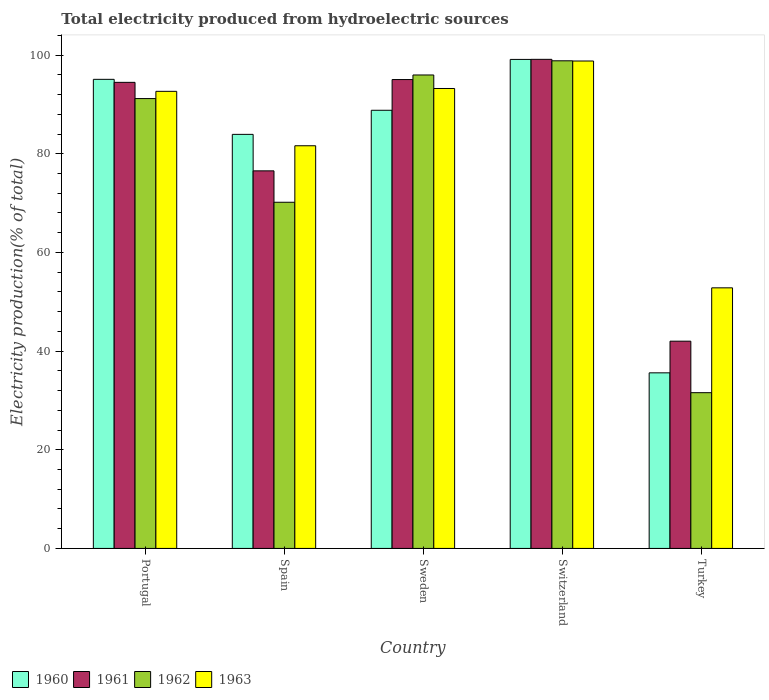How many different coloured bars are there?
Provide a short and direct response. 4. How many groups of bars are there?
Your answer should be very brief. 5. How many bars are there on the 4th tick from the left?
Offer a terse response. 4. How many bars are there on the 3rd tick from the right?
Offer a very short reply. 4. What is the total electricity produced in 1960 in Switzerland?
Keep it short and to the point. 99.13. Across all countries, what is the maximum total electricity produced in 1960?
Your answer should be compact. 99.13. Across all countries, what is the minimum total electricity produced in 1963?
Offer a terse response. 52.82. In which country was the total electricity produced in 1961 maximum?
Provide a short and direct response. Switzerland. In which country was the total electricity produced in 1963 minimum?
Offer a very short reply. Turkey. What is the total total electricity produced in 1963 in the graph?
Offer a terse response. 419.15. What is the difference between the total electricity produced in 1960 in Portugal and that in Switzerland?
Your answer should be compact. -4.04. What is the difference between the total electricity produced in 1961 in Sweden and the total electricity produced in 1963 in Switzerland?
Offer a terse response. -3.76. What is the average total electricity produced in 1963 per country?
Provide a succinct answer. 83.83. What is the difference between the total electricity produced of/in 1963 and total electricity produced of/in 1961 in Spain?
Give a very brief answer. 5.09. What is the ratio of the total electricity produced in 1963 in Spain to that in Turkey?
Make the answer very short. 1.55. Is the total electricity produced in 1963 in Portugal less than that in Switzerland?
Offer a very short reply. Yes. What is the difference between the highest and the second highest total electricity produced in 1962?
Your response must be concise. 7.65. What is the difference between the highest and the lowest total electricity produced in 1960?
Ensure brevity in your answer.  63.54. Is the sum of the total electricity produced in 1960 in Switzerland and Turkey greater than the maximum total electricity produced in 1962 across all countries?
Your response must be concise. Yes. Is it the case that in every country, the sum of the total electricity produced in 1962 and total electricity produced in 1960 is greater than the sum of total electricity produced in 1961 and total electricity produced in 1963?
Make the answer very short. No. What does the 3rd bar from the left in Portugal represents?
Offer a terse response. 1962. Is it the case that in every country, the sum of the total electricity produced in 1961 and total electricity produced in 1963 is greater than the total electricity produced in 1960?
Keep it short and to the point. Yes. How many countries are there in the graph?
Make the answer very short. 5. What is the difference between two consecutive major ticks on the Y-axis?
Ensure brevity in your answer.  20. Where does the legend appear in the graph?
Your response must be concise. Bottom left. How many legend labels are there?
Your answer should be very brief. 4. How are the legend labels stacked?
Offer a terse response. Horizontal. What is the title of the graph?
Keep it short and to the point. Total electricity produced from hydroelectric sources. What is the label or title of the X-axis?
Your answer should be compact. Country. What is the label or title of the Y-axis?
Give a very brief answer. Electricity production(% of total). What is the Electricity production(% of total) of 1960 in Portugal?
Your answer should be very brief. 95.09. What is the Electricity production(% of total) of 1961 in Portugal?
Your response must be concise. 94.48. What is the Electricity production(% of total) in 1962 in Portugal?
Offer a terse response. 91.19. What is the Electricity production(% of total) of 1963 in Portugal?
Keep it short and to the point. 92.66. What is the Electricity production(% of total) in 1960 in Spain?
Make the answer very short. 83.94. What is the Electricity production(% of total) in 1961 in Spain?
Make the answer very short. 76.54. What is the Electricity production(% of total) in 1962 in Spain?
Ensure brevity in your answer.  70.17. What is the Electricity production(% of total) in 1963 in Spain?
Provide a succinct answer. 81.63. What is the Electricity production(% of total) in 1960 in Sweden?
Provide a short and direct response. 88.82. What is the Electricity production(% of total) in 1961 in Sweden?
Your response must be concise. 95.05. What is the Electricity production(% of total) of 1962 in Sweden?
Your response must be concise. 95.98. What is the Electricity production(% of total) in 1963 in Sweden?
Give a very brief answer. 93.24. What is the Electricity production(% of total) in 1960 in Switzerland?
Your answer should be very brief. 99.13. What is the Electricity production(% of total) of 1961 in Switzerland?
Your answer should be compact. 99.15. What is the Electricity production(% of total) in 1962 in Switzerland?
Your answer should be very brief. 98.85. What is the Electricity production(% of total) of 1963 in Switzerland?
Provide a succinct answer. 98.81. What is the Electricity production(% of total) of 1960 in Turkey?
Make the answer very short. 35.6. What is the Electricity production(% of total) in 1961 in Turkey?
Offer a terse response. 42.01. What is the Electricity production(% of total) in 1962 in Turkey?
Your answer should be compact. 31.57. What is the Electricity production(% of total) of 1963 in Turkey?
Keep it short and to the point. 52.82. Across all countries, what is the maximum Electricity production(% of total) of 1960?
Provide a short and direct response. 99.13. Across all countries, what is the maximum Electricity production(% of total) of 1961?
Your answer should be compact. 99.15. Across all countries, what is the maximum Electricity production(% of total) of 1962?
Your response must be concise. 98.85. Across all countries, what is the maximum Electricity production(% of total) of 1963?
Offer a very short reply. 98.81. Across all countries, what is the minimum Electricity production(% of total) of 1960?
Provide a short and direct response. 35.6. Across all countries, what is the minimum Electricity production(% of total) in 1961?
Your response must be concise. 42.01. Across all countries, what is the minimum Electricity production(% of total) of 1962?
Your answer should be very brief. 31.57. Across all countries, what is the minimum Electricity production(% of total) in 1963?
Keep it short and to the point. 52.82. What is the total Electricity production(% of total) in 1960 in the graph?
Ensure brevity in your answer.  402.57. What is the total Electricity production(% of total) of 1961 in the graph?
Make the answer very short. 407.23. What is the total Electricity production(% of total) in 1962 in the graph?
Ensure brevity in your answer.  387.76. What is the total Electricity production(% of total) in 1963 in the graph?
Ensure brevity in your answer.  419.15. What is the difference between the Electricity production(% of total) of 1960 in Portugal and that in Spain?
Offer a very short reply. 11.15. What is the difference between the Electricity production(% of total) in 1961 in Portugal and that in Spain?
Give a very brief answer. 17.94. What is the difference between the Electricity production(% of total) of 1962 in Portugal and that in Spain?
Make the answer very short. 21.02. What is the difference between the Electricity production(% of total) of 1963 in Portugal and that in Spain?
Offer a terse response. 11.03. What is the difference between the Electricity production(% of total) in 1960 in Portugal and that in Sweden?
Provide a succinct answer. 6.27. What is the difference between the Electricity production(% of total) of 1961 in Portugal and that in Sweden?
Provide a short and direct response. -0.57. What is the difference between the Electricity production(% of total) in 1962 in Portugal and that in Sweden?
Keep it short and to the point. -4.78. What is the difference between the Electricity production(% of total) of 1963 in Portugal and that in Sweden?
Provide a succinct answer. -0.58. What is the difference between the Electricity production(% of total) in 1960 in Portugal and that in Switzerland?
Give a very brief answer. -4.04. What is the difference between the Electricity production(% of total) of 1961 in Portugal and that in Switzerland?
Your response must be concise. -4.67. What is the difference between the Electricity production(% of total) of 1962 in Portugal and that in Switzerland?
Offer a very short reply. -7.65. What is the difference between the Electricity production(% of total) of 1963 in Portugal and that in Switzerland?
Ensure brevity in your answer.  -6.15. What is the difference between the Electricity production(% of total) in 1960 in Portugal and that in Turkey?
Offer a very short reply. 59.49. What is the difference between the Electricity production(% of total) in 1961 in Portugal and that in Turkey?
Your answer should be compact. 52.47. What is the difference between the Electricity production(% of total) in 1962 in Portugal and that in Turkey?
Your answer should be compact. 59.62. What is the difference between the Electricity production(% of total) in 1963 in Portugal and that in Turkey?
Offer a very short reply. 39.84. What is the difference between the Electricity production(% of total) of 1960 in Spain and that in Sweden?
Your answer should be compact. -4.88. What is the difference between the Electricity production(% of total) in 1961 in Spain and that in Sweden?
Provide a short and direct response. -18.51. What is the difference between the Electricity production(% of total) of 1962 in Spain and that in Sweden?
Your answer should be very brief. -25.8. What is the difference between the Electricity production(% of total) in 1963 in Spain and that in Sweden?
Ensure brevity in your answer.  -11.61. What is the difference between the Electricity production(% of total) of 1960 in Spain and that in Switzerland?
Keep it short and to the point. -15.19. What is the difference between the Electricity production(% of total) in 1961 in Spain and that in Switzerland?
Provide a succinct answer. -22.61. What is the difference between the Electricity production(% of total) in 1962 in Spain and that in Switzerland?
Offer a terse response. -28.67. What is the difference between the Electricity production(% of total) of 1963 in Spain and that in Switzerland?
Offer a very short reply. -17.18. What is the difference between the Electricity production(% of total) in 1960 in Spain and that in Turkey?
Your response must be concise. 48.34. What is the difference between the Electricity production(% of total) in 1961 in Spain and that in Turkey?
Keep it short and to the point. 34.53. What is the difference between the Electricity production(% of total) in 1962 in Spain and that in Turkey?
Your answer should be compact. 38.6. What is the difference between the Electricity production(% of total) in 1963 in Spain and that in Turkey?
Provide a succinct answer. 28.8. What is the difference between the Electricity production(% of total) in 1960 in Sweden and that in Switzerland?
Provide a succinct answer. -10.31. What is the difference between the Electricity production(% of total) of 1961 in Sweden and that in Switzerland?
Keep it short and to the point. -4.1. What is the difference between the Electricity production(% of total) of 1962 in Sweden and that in Switzerland?
Provide a succinct answer. -2.87. What is the difference between the Electricity production(% of total) of 1963 in Sweden and that in Switzerland?
Your answer should be very brief. -5.57. What is the difference between the Electricity production(% of total) in 1960 in Sweden and that in Turkey?
Keep it short and to the point. 53.22. What is the difference between the Electricity production(% of total) of 1961 in Sweden and that in Turkey?
Give a very brief answer. 53.04. What is the difference between the Electricity production(% of total) in 1962 in Sweden and that in Turkey?
Keep it short and to the point. 64.4. What is the difference between the Electricity production(% of total) of 1963 in Sweden and that in Turkey?
Ensure brevity in your answer.  40.41. What is the difference between the Electricity production(% of total) of 1960 in Switzerland and that in Turkey?
Provide a succinct answer. 63.54. What is the difference between the Electricity production(% of total) of 1961 in Switzerland and that in Turkey?
Give a very brief answer. 57.13. What is the difference between the Electricity production(% of total) in 1962 in Switzerland and that in Turkey?
Provide a short and direct response. 67.27. What is the difference between the Electricity production(% of total) in 1963 in Switzerland and that in Turkey?
Your response must be concise. 45.98. What is the difference between the Electricity production(% of total) of 1960 in Portugal and the Electricity production(% of total) of 1961 in Spain?
Your answer should be compact. 18.55. What is the difference between the Electricity production(% of total) of 1960 in Portugal and the Electricity production(% of total) of 1962 in Spain?
Ensure brevity in your answer.  24.92. What is the difference between the Electricity production(% of total) in 1960 in Portugal and the Electricity production(% of total) in 1963 in Spain?
Your answer should be compact. 13.46. What is the difference between the Electricity production(% of total) in 1961 in Portugal and the Electricity production(% of total) in 1962 in Spain?
Make the answer very short. 24.31. What is the difference between the Electricity production(% of total) in 1961 in Portugal and the Electricity production(% of total) in 1963 in Spain?
Provide a short and direct response. 12.85. What is the difference between the Electricity production(% of total) of 1962 in Portugal and the Electricity production(% of total) of 1963 in Spain?
Your answer should be very brief. 9.57. What is the difference between the Electricity production(% of total) in 1960 in Portugal and the Electricity production(% of total) in 1961 in Sweden?
Ensure brevity in your answer.  0.04. What is the difference between the Electricity production(% of total) of 1960 in Portugal and the Electricity production(% of total) of 1962 in Sweden?
Ensure brevity in your answer.  -0.89. What is the difference between the Electricity production(% of total) in 1960 in Portugal and the Electricity production(% of total) in 1963 in Sweden?
Your response must be concise. 1.85. What is the difference between the Electricity production(% of total) of 1961 in Portugal and the Electricity production(% of total) of 1962 in Sweden?
Provide a succinct answer. -1.49. What is the difference between the Electricity production(% of total) of 1961 in Portugal and the Electricity production(% of total) of 1963 in Sweden?
Provide a succinct answer. 1.24. What is the difference between the Electricity production(% of total) in 1962 in Portugal and the Electricity production(% of total) in 1963 in Sweden?
Offer a terse response. -2.04. What is the difference between the Electricity production(% of total) of 1960 in Portugal and the Electricity production(% of total) of 1961 in Switzerland?
Your response must be concise. -4.06. What is the difference between the Electricity production(% of total) in 1960 in Portugal and the Electricity production(% of total) in 1962 in Switzerland?
Provide a short and direct response. -3.76. What is the difference between the Electricity production(% of total) in 1960 in Portugal and the Electricity production(% of total) in 1963 in Switzerland?
Keep it short and to the point. -3.72. What is the difference between the Electricity production(% of total) in 1961 in Portugal and the Electricity production(% of total) in 1962 in Switzerland?
Give a very brief answer. -4.37. What is the difference between the Electricity production(% of total) in 1961 in Portugal and the Electricity production(% of total) in 1963 in Switzerland?
Offer a very short reply. -4.33. What is the difference between the Electricity production(% of total) in 1962 in Portugal and the Electricity production(% of total) in 1963 in Switzerland?
Give a very brief answer. -7.61. What is the difference between the Electricity production(% of total) of 1960 in Portugal and the Electricity production(% of total) of 1961 in Turkey?
Offer a terse response. 53.08. What is the difference between the Electricity production(% of total) of 1960 in Portugal and the Electricity production(% of total) of 1962 in Turkey?
Your answer should be very brief. 63.52. What is the difference between the Electricity production(% of total) in 1960 in Portugal and the Electricity production(% of total) in 1963 in Turkey?
Offer a terse response. 42.27. What is the difference between the Electricity production(% of total) in 1961 in Portugal and the Electricity production(% of total) in 1962 in Turkey?
Your answer should be compact. 62.91. What is the difference between the Electricity production(% of total) in 1961 in Portugal and the Electricity production(% of total) in 1963 in Turkey?
Make the answer very short. 41.66. What is the difference between the Electricity production(% of total) of 1962 in Portugal and the Electricity production(% of total) of 1963 in Turkey?
Offer a terse response. 38.37. What is the difference between the Electricity production(% of total) in 1960 in Spain and the Electricity production(% of total) in 1961 in Sweden?
Your answer should be very brief. -11.11. What is the difference between the Electricity production(% of total) in 1960 in Spain and the Electricity production(% of total) in 1962 in Sweden?
Make the answer very short. -12.04. What is the difference between the Electricity production(% of total) in 1960 in Spain and the Electricity production(% of total) in 1963 in Sweden?
Give a very brief answer. -9.3. What is the difference between the Electricity production(% of total) of 1961 in Spain and the Electricity production(% of total) of 1962 in Sweden?
Your answer should be very brief. -19.44. What is the difference between the Electricity production(% of total) of 1961 in Spain and the Electricity production(% of total) of 1963 in Sweden?
Make the answer very short. -16.7. What is the difference between the Electricity production(% of total) in 1962 in Spain and the Electricity production(% of total) in 1963 in Sweden?
Give a very brief answer. -23.06. What is the difference between the Electricity production(% of total) in 1960 in Spain and the Electricity production(% of total) in 1961 in Switzerland?
Provide a succinct answer. -15.21. What is the difference between the Electricity production(% of total) in 1960 in Spain and the Electricity production(% of total) in 1962 in Switzerland?
Give a very brief answer. -14.91. What is the difference between the Electricity production(% of total) of 1960 in Spain and the Electricity production(% of total) of 1963 in Switzerland?
Your answer should be compact. -14.87. What is the difference between the Electricity production(% of total) in 1961 in Spain and the Electricity production(% of total) in 1962 in Switzerland?
Offer a terse response. -22.31. What is the difference between the Electricity production(% of total) of 1961 in Spain and the Electricity production(% of total) of 1963 in Switzerland?
Provide a short and direct response. -22.27. What is the difference between the Electricity production(% of total) of 1962 in Spain and the Electricity production(% of total) of 1963 in Switzerland?
Your response must be concise. -28.63. What is the difference between the Electricity production(% of total) of 1960 in Spain and the Electricity production(% of total) of 1961 in Turkey?
Provide a short and direct response. 41.92. What is the difference between the Electricity production(% of total) in 1960 in Spain and the Electricity production(% of total) in 1962 in Turkey?
Ensure brevity in your answer.  52.36. What is the difference between the Electricity production(% of total) of 1960 in Spain and the Electricity production(% of total) of 1963 in Turkey?
Your answer should be compact. 31.11. What is the difference between the Electricity production(% of total) in 1961 in Spain and the Electricity production(% of total) in 1962 in Turkey?
Provide a succinct answer. 44.97. What is the difference between the Electricity production(% of total) of 1961 in Spain and the Electricity production(% of total) of 1963 in Turkey?
Give a very brief answer. 23.72. What is the difference between the Electricity production(% of total) of 1962 in Spain and the Electricity production(% of total) of 1963 in Turkey?
Provide a short and direct response. 17.35. What is the difference between the Electricity production(% of total) in 1960 in Sweden and the Electricity production(% of total) in 1961 in Switzerland?
Provide a short and direct response. -10.33. What is the difference between the Electricity production(% of total) in 1960 in Sweden and the Electricity production(% of total) in 1962 in Switzerland?
Offer a very short reply. -10.03. What is the difference between the Electricity production(% of total) in 1960 in Sweden and the Electricity production(% of total) in 1963 in Switzerland?
Offer a terse response. -9.99. What is the difference between the Electricity production(% of total) of 1961 in Sweden and the Electricity production(% of total) of 1962 in Switzerland?
Provide a short and direct response. -3.8. What is the difference between the Electricity production(% of total) in 1961 in Sweden and the Electricity production(% of total) in 1963 in Switzerland?
Keep it short and to the point. -3.76. What is the difference between the Electricity production(% of total) in 1962 in Sweden and the Electricity production(% of total) in 1963 in Switzerland?
Provide a succinct answer. -2.83. What is the difference between the Electricity production(% of total) of 1960 in Sweden and the Electricity production(% of total) of 1961 in Turkey?
Your answer should be compact. 46.81. What is the difference between the Electricity production(% of total) in 1960 in Sweden and the Electricity production(% of total) in 1962 in Turkey?
Provide a short and direct response. 57.25. What is the difference between the Electricity production(% of total) in 1960 in Sweden and the Electricity production(% of total) in 1963 in Turkey?
Give a very brief answer. 36. What is the difference between the Electricity production(% of total) of 1961 in Sweden and the Electricity production(% of total) of 1962 in Turkey?
Offer a very short reply. 63.48. What is the difference between the Electricity production(% of total) in 1961 in Sweden and the Electricity production(% of total) in 1963 in Turkey?
Your answer should be compact. 42.22. What is the difference between the Electricity production(% of total) in 1962 in Sweden and the Electricity production(% of total) in 1963 in Turkey?
Make the answer very short. 43.15. What is the difference between the Electricity production(% of total) in 1960 in Switzerland and the Electricity production(% of total) in 1961 in Turkey?
Provide a short and direct response. 57.12. What is the difference between the Electricity production(% of total) in 1960 in Switzerland and the Electricity production(% of total) in 1962 in Turkey?
Offer a very short reply. 67.56. What is the difference between the Electricity production(% of total) in 1960 in Switzerland and the Electricity production(% of total) in 1963 in Turkey?
Your answer should be compact. 46.31. What is the difference between the Electricity production(% of total) in 1961 in Switzerland and the Electricity production(% of total) in 1962 in Turkey?
Your answer should be compact. 67.57. What is the difference between the Electricity production(% of total) of 1961 in Switzerland and the Electricity production(% of total) of 1963 in Turkey?
Provide a succinct answer. 46.32. What is the difference between the Electricity production(% of total) in 1962 in Switzerland and the Electricity production(% of total) in 1963 in Turkey?
Provide a succinct answer. 46.02. What is the average Electricity production(% of total) of 1960 per country?
Offer a terse response. 80.51. What is the average Electricity production(% of total) in 1961 per country?
Offer a very short reply. 81.45. What is the average Electricity production(% of total) in 1962 per country?
Your answer should be very brief. 77.55. What is the average Electricity production(% of total) in 1963 per country?
Your answer should be compact. 83.83. What is the difference between the Electricity production(% of total) of 1960 and Electricity production(% of total) of 1961 in Portugal?
Ensure brevity in your answer.  0.61. What is the difference between the Electricity production(% of total) of 1960 and Electricity production(% of total) of 1962 in Portugal?
Ensure brevity in your answer.  3.9. What is the difference between the Electricity production(% of total) of 1960 and Electricity production(% of total) of 1963 in Portugal?
Offer a very short reply. 2.43. What is the difference between the Electricity production(% of total) of 1961 and Electricity production(% of total) of 1962 in Portugal?
Your answer should be compact. 3.29. What is the difference between the Electricity production(% of total) of 1961 and Electricity production(% of total) of 1963 in Portugal?
Make the answer very short. 1.82. What is the difference between the Electricity production(% of total) in 1962 and Electricity production(% of total) in 1963 in Portugal?
Give a very brief answer. -1.47. What is the difference between the Electricity production(% of total) in 1960 and Electricity production(% of total) in 1961 in Spain?
Provide a succinct answer. 7.4. What is the difference between the Electricity production(% of total) in 1960 and Electricity production(% of total) in 1962 in Spain?
Your answer should be very brief. 13.76. What is the difference between the Electricity production(% of total) in 1960 and Electricity production(% of total) in 1963 in Spain?
Make the answer very short. 2.31. What is the difference between the Electricity production(% of total) in 1961 and Electricity production(% of total) in 1962 in Spain?
Your answer should be very brief. 6.37. What is the difference between the Electricity production(% of total) in 1961 and Electricity production(% of total) in 1963 in Spain?
Provide a succinct answer. -5.09. What is the difference between the Electricity production(% of total) of 1962 and Electricity production(% of total) of 1963 in Spain?
Offer a terse response. -11.45. What is the difference between the Electricity production(% of total) of 1960 and Electricity production(% of total) of 1961 in Sweden?
Keep it short and to the point. -6.23. What is the difference between the Electricity production(% of total) of 1960 and Electricity production(% of total) of 1962 in Sweden?
Keep it short and to the point. -7.16. What is the difference between the Electricity production(% of total) of 1960 and Electricity production(% of total) of 1963 in Sweden?
Your response must be concise. -4.42. What is the difference between the Electricity production(% of total) of 1961 and Electricity production(% of total) of 1962 in Sweden?
Your response must be concise. -0.93. What is the difference between the Electricity production(% of total) in 1961 and Electricity production(% of total) in 1963 in Sweden?
Provide a succinct answer. 1.81. What is the difference between the Electricity production(% of total) of 1962 and Electricity production(% of total) of 1963 in Sweden?
Your answer should be very brief. 2.74. What is the difference between the Electricity production(% of total) in 1960 and Electricity production(% of total) in 1961 in Switzerland?
Provide a short and direct response. -0.02. What is the difference between the Electricity production(% of total) of 1960 and Electricity production(% of total) of 1962 in Switzerland?
Keep it short and to the point. 0.28. What is the difference between the Electricity production(% of total) of 1960 and Electricity production(% of total) of 1963 in Switzerland?
Give a very brief answer. 0.32. What is the difference between the Electricity production(% of total) of 1961 and Electricity production(% of total) of 1962 in Switzerland?
Your answer should be very brief. 0.3. What is the difference between the Electricity production(% of total) of 1961 and Electricity production(% of total) of 1963 in Switzerland?
Your response must be concise. 0.34. What is the difference between the Electricity production(% of total) in 1962 and Electricity production(% of total) in 1963 in Switzerland?
Offer a terse response. 0.04. What is the difference between the Electricity production(% of total) in 1960 and Electricity production(% of total) in 1961 in Turkey?
Offer a very short reply. -6.42. What is the difference between the Electricity production(% of total) in 1960 and Electricity production(% of total) in 1962 in Turkey?
Keep it short and to the point. 4.02. What is the difference between the Electricity production(% of total) of 1960 and Electricity production(% of total) of 1963 in Turkey?
Keep it short and to the point. -17.23. What is the difference between the Electricity production(% of total) in 1961 and Electricity production(% of total) in 1962 in Turkey?
Ensure brevity in your answer.  10.44. What is the difference between the Electricity production(% of total) in 1961 and Electricity production(% of total) in 1963 in Turkey?
Offer a very short reply. -10.81. What is the difference between the Electricity production(% of total) in 1962 and Electricity production(% of total) in 1963 in Turkey?
Your answer should be very brief. -21.25. What is the ratio of the Electricity production(% of total) of 1960 in Portugal to that in Spain?
Ensure brevity in your answer.  1.13. What is the ratio of the Electricity production(% of total) of 1961 in Portugal to that in Spain?
Offer a terse response. 1.23. What is the ratio of the Electricity production(% of total) in 1962 in Portugal to that in Spain?
Offer a terse response. 1.3. What is the ratio of the Electricity production(% of total) in 1963 in Portugal to that in Spain?
Provide a succinct answer. 1.14. What is the ratio of the Electricity production(% of total) of 1960 in Portugal to that in Sweden?
Provide a short and direct response. 1.07. What is the ratio of the Electricity production(% of total) in 1961 in Portugal to that in Sweden?
Provide a short and direct response. 0.99. What is the ratio of the Electricity production(% of total) in 1962 in Portugal to that in Sweden?
Offer a terse response. 0.95. What is the ratio of the Electricity production(% of total) of 1960 in Portugal to that in Switzerland?
Keep it short and to the point. 0.96. What is the ratio of the Electricity production(% of total) in 1961 in Portugal to that in Switzerland?
Keep it short and to the point. 0.95. What is the ratio of the Electricity production(% of total) of 1962 in Portugal to that in Switzerland?
Keep it short and to the point. 0.92. What is the ratio of the Electricity production(% of total) in 1963 in Portugal to that in Switzerland?
Keep it short and to the point. 0.94. What is the ratio of the Electricity production(% of total) in 1960 in Portugal to that in Turkey?
Provide a short and direct response. 2.67. What is the ratio of the Electricity production(% of total) in 1961 in Portugal to that in Turkey?
Provide a short and direct response. 2.25. What is the ratio of the Electricity production(% of total) of 1962 in Portugal to that in Turkey?
Your answer should be compact. 2.89. What is the ratio of the Electricity production(% of total) of 1963 in Portugal to that in Turkey?
Your response must be concise. 1.75. What is the ratio of the Electricity production(% of total) of 1960 in Spain to that in Sweden?
Ensure brevity in your answer.  0.94. What is the ratio of the Electricity production(% of total) of 1961 in Spain to that in Sweden?
Make the answer very short. 0.81. What is the ratio of the Electricity production(% of total) of 1962 in Spain to that in Sweden?
Offer a very short reply. 0.73. What is the ratio of the Electricity production(% of total) of 1963 in Spain to that in Sweden?
Keep it short and to the point. 0.88. What is the ratio of the Electricity production(% of total) in 1960 in Spain to that in Switzerland?
Ensure brevity in your answer.  0.85. What is the ratio of the Electricity production(% of total) in 1961 in Spain to that in Switzerland?
Provide a succinct answer. 0.77. What is the ratio of the Electricity production(% of total) in 1962 in Spain to that in Switzerland?
Provide a succinct answer. 0.71. What is the ratio of the Electricity production(% of total) in 1963 in Spain to that in Switzerland?
Offer a very short reply. 0.83. What is the ratio of the Electricity production(% of total) of 1960 in Spain to that in Turkey?
Provide a short and direct response. 2.36. What is the ratio of the Electricity production(% of total) of 1961 in Spain to that in Turkey?
Make the answer very short. 1.82. What is the ratio of the Electricity production(% of total) of 1962 in Spain to that in Turkey?
Your response must be concise. 2.22. What is the ratio of the Electricity production(% of total) in 1963 in Spain to that in Turkey?
Offer a very short reply. 1.55. What is the ratio of the Electricity production(% of total) in 1960 in Sweden to that in Switzerland?
Provide a short and direct response. 0.9. What is the ratio of the Electricity production(% of total) of 1961 in Sweden to that in Switzerland?
Your response must be concise. 0.96. What is the ratio of the Electricity production(% of total) of 1962 in Sweden to that in Switzerland?
Your answer should be compact. 0.97. What is the ratio of the Electricity production(% of total) in 1963 in Sweden to that in Switzerland?
Provide a short and direct response. 0.94. What is the ratio of the Electricity production(% of total) in 1960 in Sweden to that in Turkey?
Provide a succinct answer. 2.5. What is the ratio of the Electricity production(% of total) of 1961 in Sweden to that in Turkey?
Provide a short and direct response. 2.26. What is the ratio of the Electricity production(% of total) in 1962 in Sweden to that in Turkey?
Your answer should be very brief. 3.04. What is the ratio of the Electricity production(% of total) of 1963 in Sweden to that in Turkey?
Give a very brief answer. 1.76. What is the ratio of the Electricity production(% of total) of 1960 in Switzerland to that in Turkey?
Provide a succinct answer. 2.79. What is the ratio of the Electricity production(% of total) in 1961 in Switzerland to that in Turkey?
Offer a very short reply. 2.36. What is the ratio of the Electricity production(% of total) in 1962 in Switzerland to that in Turkey?
Your answer should be very brief. 3.13. What is the ratio of the Electricity production(% of total) in 1963 in Switzerland to that in Turkey?
Offer a very short reply. 1.87. What is the difference between the highest and the second highest Electricity production(% of total) of 1960?
Ensure brevity in your answer.  4.04. What is the difference between the highest and the second highest Electricity production(% of total) in 1961?
Provide a succinct answer. 4.1. What is the difference between the highest and the second highest Electricity production(% of total) of 1962?
Your response must be concise. 2.87. What is the difference between the highest and the second highest Electricity production(% of total) in 1963?
Keep it short and to the point. 5.57. What is the difference between the highest and the lowest Electricity production(% of total) in 1960?
Your response must be concise. 63.54. What is the difference between the highest and the lowest Electricity production(% of total) in 1961?
Your answer should be very brief. 57.13. What is the difference between the highest and the lowest Electricity production(% of total) in 1962?
Your answer should be compact. 67.27. What is the difference between the highest and the lowest Electricity production(% of total) in 1963?
Your response must be concise. 45.98. 